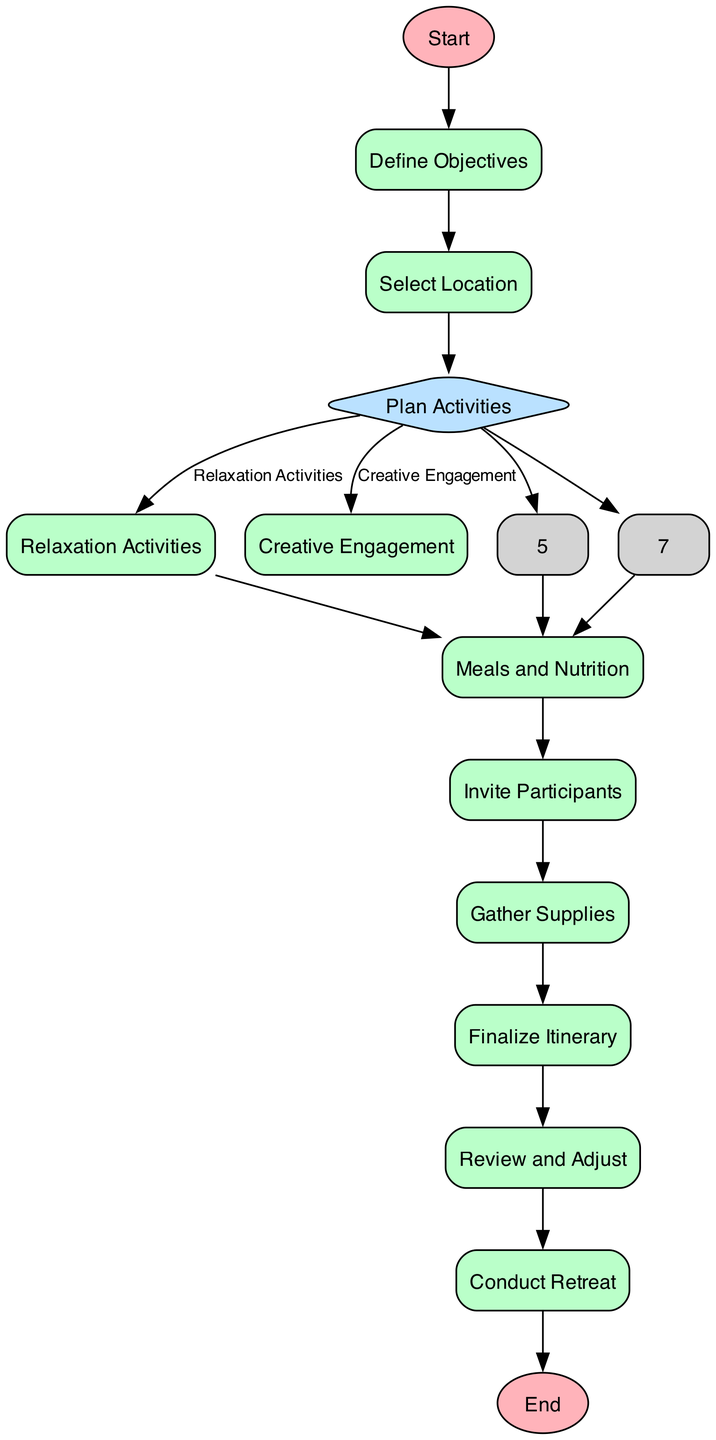What is the first step in the retreat planning process? The first step in the retreat planning process is represented by the node labeled "Start," which indicates the beginning of the process flow.
Answer: Start How many decision points are in the diagram? The diagram has one decision point, which is where activities are determined to be either relaxation activities or creative engagement. This is indicated by the node labeled "Plan Activities."
Answer: 1 What activity happens after selecting a location? After selecting a location, the next activity is to "Plan Activities," as indicated by the transition that connects these two nodes in the flowchart.
Answer: Plan Activities What two types of activities can be planned? The two types of activities that can be planned are "Relaxation Activities" and "Creative Engagement," as specified in the options of the decision node "Plan Activities."
Answer: Relaxation Activities and Creative Engagement How many processes are there in total? By counting all the nodes labeled as processes, we find there are a total of eight process nodes in the diagram, including the ones for defining objectives, selecting locations, organizing activities, etc.
Answer: 8 What is the last step before conducting the retreat? The last step before conducting the retreat is "Review and Adjust," as per the transition that leads directly into conducting the actual retreat.
Answer: Review and Adjust What describes the process of finalizing the itinerary? Finalizing the itinerary involves creating a detailed schedule including activity sessions, meal times, and free time, as described in the node labeled "Finalize Itinerary."
Answer: Creating a detailed schedule What happens after planning meals and nutrition? After planning meals and nutrition, the next step is to "Invite Participants," as indicated by the transition leading from the meals process node to the invitations process node.
Answer: Invite Participants 